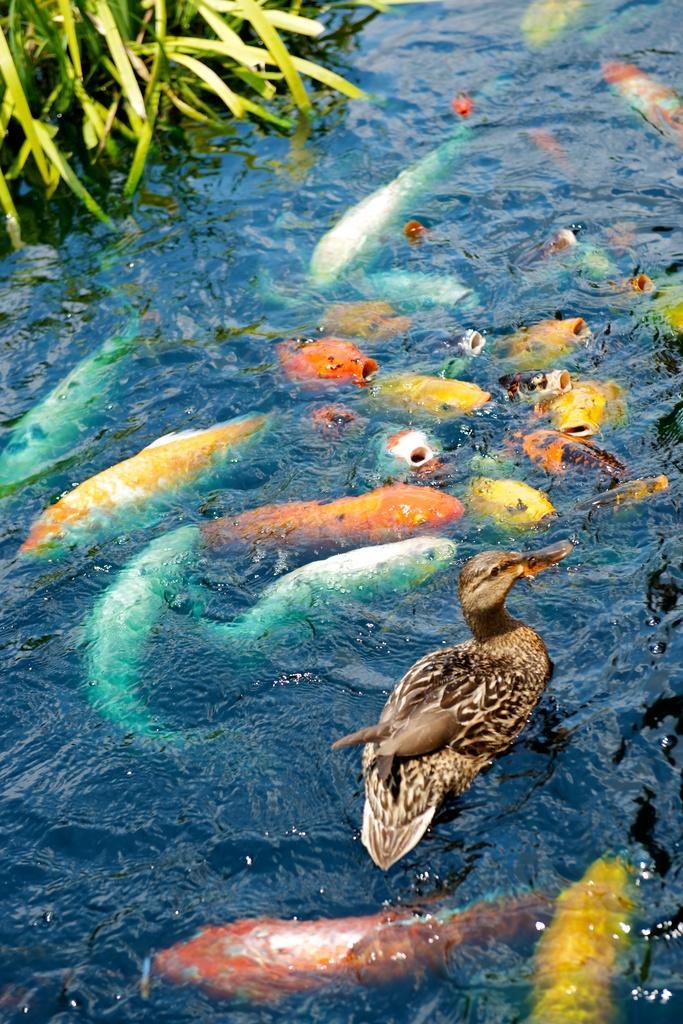In one or two sentences, can you explain what this image depicts? In the image there is water. There is a duck in the water. And also there are colorful fishes inside the water. In the top left corner of the image there are leaves. 